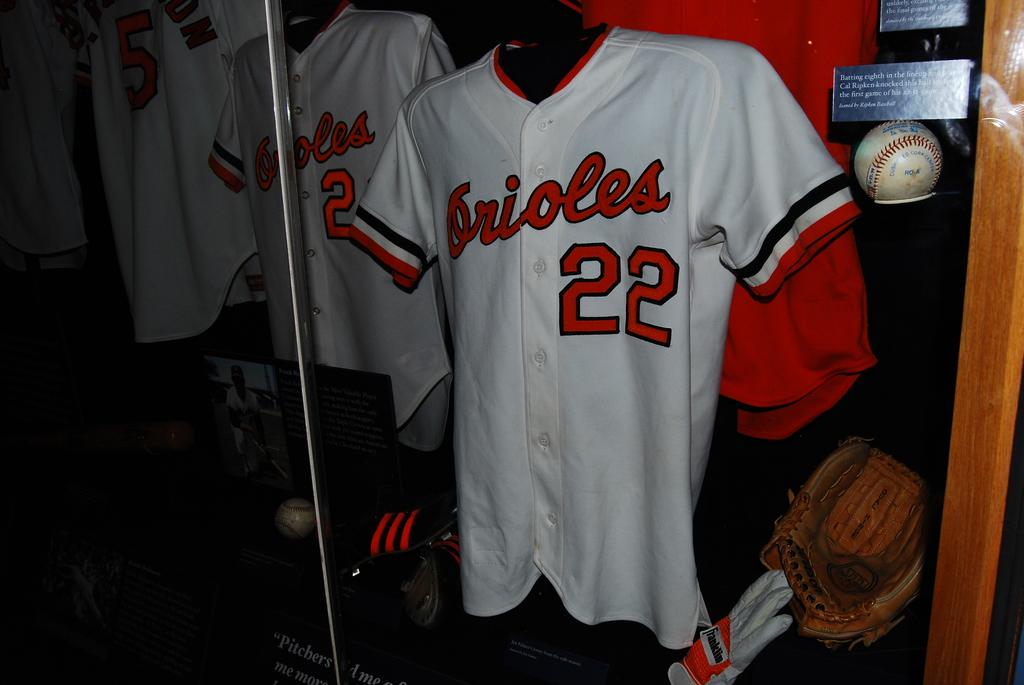Provide a one-sentence caption for the provided image. A jersey in a display case that is Orioles number 22 next to a ball and mitt. 